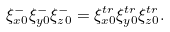Convert formula to latex. <formula><loc_0><loc_0><loc_500><loc_500>\xi _ { x 0 } ^ { - } \xi _ { y 0 } ^ { - } \xi _ { z 0 } ^ { - } = \xi _ { x 0 } ^ { t r } \xi _ { y 0 } ^ { t r } \xi _ { z 0 } ^ { t r } .</formula> 